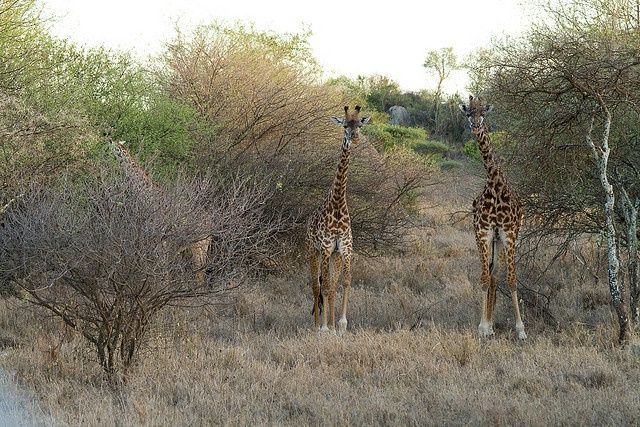Describe the objects in this image and their specific colors. I can see giraffe in olive, gray, and black tones, giraffe in olive, gray, and black tones, and giraffe in olive, gray, and darkgray tones in this image. 